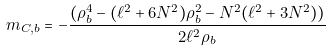<formula> <loc_0><loc_0><loc_500><loc_500>m _ { C , b } = - \frac { ( \rho _ { b } ^ { 4 } - ( \ell ^ { 2 } + 6 N ^ { 2 } ) \rho _ { b } ^ { 2 } - N ^ { 2 } ( \ell ^ { 2 } + 3 N ^ { 2 } ) ) } { 2 \ell ^ { 2 } \rho _ { b } }</formula> 